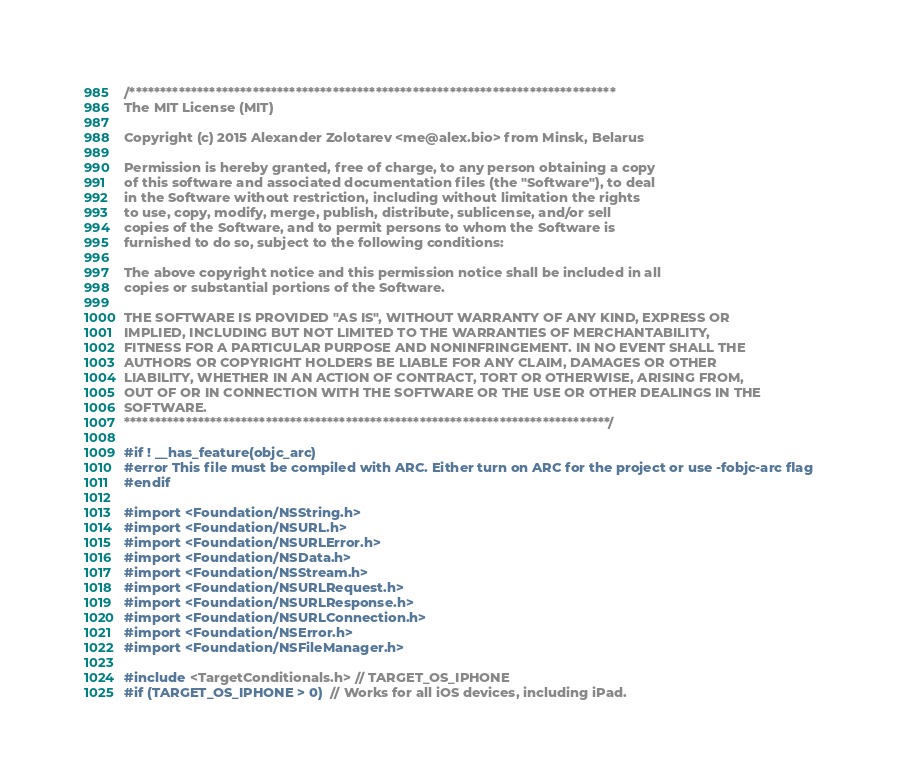Convert code to text. <code><loc_0><loc_0><loc_500><loc_500><_ObjectiveC_>/*******************************************************************************
The MIT License (MIT)

Copyright (c) 2015 Alexander Zolotarev <me@alex.bio> from Minsk, Belarus

Permission is hereby granted, free of charge, to any person obtaining a copy
of this software and associated documentation files (the "Software"), to deal
in the Software without restriction, including without limitation the rights
to use, copy, modify, merge, publish, distribute, sublicense, and/or sell
copies of the Software, and to permit persons to whom the Software is
furnished to do so, subject to the following conditions:

The above copyright notice and this permission notice shall be included in all
copies or substantial portions of the Software.

THE SOFTWARE IS PROVIDED "AS IS", WITHOUT WARRANTY OF ANY KIND, EXPRESS OR
IMPLIED, INCLUDING BUT NOT LIMITED TO THE WARRANTIES OF MERCHANTABILITY,
FITNESS FOR A PARTICULAR PURPOSE AND NONINFRINGEMENT. IN NO EVENT SHALL THE
AUTHORS OR COPYRIGHT HOLDERS BE LIABLE FOR ANY CLAIM, DAMAGES OR OTHER
LIABILITY, WHETHER IN AN ACTION OF CONTRACT, TORT OR OTHERWISE, ARISING FROM,
OUT OF OR IN CONNECTION WITH THE SOFTWARE OR THE USE OR OTHER DEALINGS IN THE
SOFTWARE.
*******************************************************************************/

#if ! __has_feature(objc_arc)
#error This file must be compiled with ARC. Either turn on ARC for the project or use -fobjc-arc flag
#endif

#import <Foundation/NSString.h>
#import <Foundation/NSURL.h>
#import <Foundation/NSURLError.h>
#import <Foundation/NSData.h>
#import <Foundation/NSStream.h>
#import <Foundation/NSURLRequest.h>
#import <Foundation/NSURLResponse.h>
#import <Foundation/NSURLConnection.h>
#import <Foundation/NSError.h>
#import <Foundation/NSFileManager.h>

#include <TargetConditionals.h> // TARGET_OS_IPHONE
#if (TARGET_OS_IPHONE > 0)  // Works for all iOS devices, including iPad.</code> 